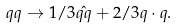Convert formula to latex. <formula><loc_0><loc_0><loc_500><loc_500>q q \rightarrow 1 / 3 \hat { q q } + 2 / 3 q \cdot q .</formula> 